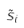Convert formula to latex. <formula><loc_0><loc_0><loc_500><loc_500>\tilde { s } _ { i }</formula> 